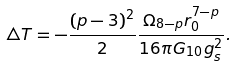<formula> <loc_0><loc_0><loc_500><loc_500>\triangle T = - \frac { ( p - 3 ) ^ { 2 } } { 2 } \frac { \Omega _ { 8 - p } r _ { 0 } ^ { 7 - p } } { 1 6 \pi G _ { 1 0 } g _ { s } ^ { 2 } } .</formula> 